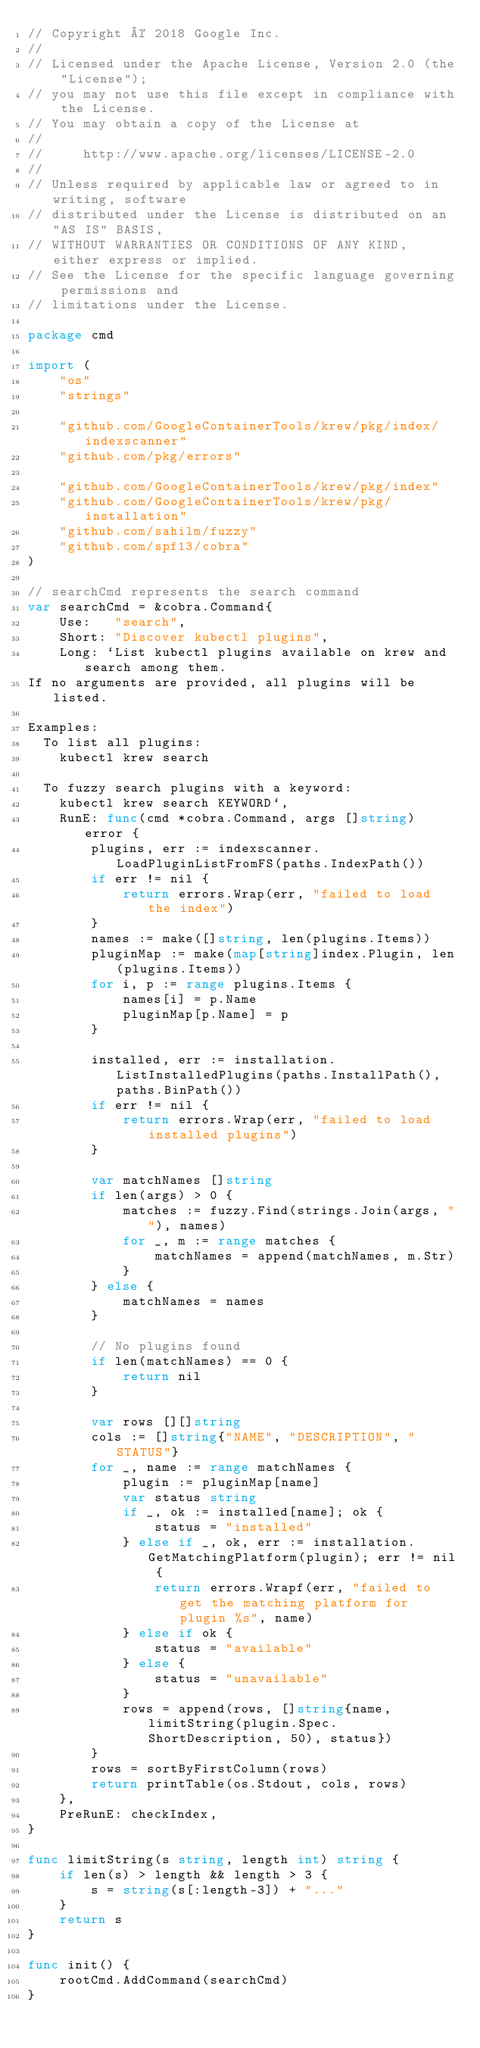Convert code to text. <code><loc_0><loc_0><loc_500><loc_500><_Go_>// Copyright © 2018 Google Inc.
//
// Licensed under the Apache License, Version 2.0 (the "License");
// you may not use this file except in compliance with the License.
// You may obtain a copy of the License at
//
//     http://www.apache.org/licenses/LICENSE-2.0
//
// Unless required by applicable law or agreed to in writing, software
// distributed under the License is distributed on an "AS IS" BASIS,
// WITHOUT WARRANTIES OR CONDITIONS OF ANY KIND, either express or implied.
// See the License for the specific language governing permissions and
// limitations under the License.

package cmd

import (
	"os"
	"strings"

	"github.com/GoogleContainerTools/krew/pkg/index/indexscanner"
	"github.com/pkg/errors"

	"github.com/GoogleContainerTools/krew/pkg/index"
	"github.com/GoogleContainerTools/krew/pkg/installation"
	"github.com/sahilm/fuzzy"
	"github.com/spf13/cobra"
)

// searchCmd represents the search command
var searchCmd = &cobra.Command{
	Use:   "search",
	Short: "Discover kubectl plugins",
	Long: `List kubectl plugins available on krew and search among them.
If no arguments are provided, all plugins will be listed.

Examples:
  To list all plugins:
    kubectl krew search

  To fuzzy search plugins with a keyword:
    kubectl krew search KEYWORD`,
	RunE: func(cmd *cobra.Command, args []string) error {
		plugins, err := indexscanner.LoadPluginListFromFS(paths.IndexPath())
		if err != nil {
			return errors.Wrap(err, "failed to load the index")
		}
		names := make([]string, len(plugins.Items))
		pluginMap := make(map[string]index.Plugin, len(plugins.Items))
		for i, p := range plugins.Items {
			names[i] = p.Name
			pluginMap[p.Name] = p
		}

		installed, err := installation.ListInstalledPlugins(paths.InstallPath(), paths.BinPath())
		if err != nil {
			return errors.Wrap(err, "failed to load installed plugins")
		}

		var matchNames []string
		if len(args) > 0 {
			matches := fuzzy.Find(strings.Join(args, ""), names)
			for _, m := range matches {
				matchNames = append(matchNames, m.Str)
			}
		} else {
			matchNames = names
		}

		// No plugins found
		if len(matchNames) == 0 {
			return nil
		}

		var rows [][]string
		cols := []string{"NAME", "DESCRIPTION", "STATUS"}
		for _, name := range matchNames {
			plugin := pluginMap[name]
			var status string
			if _, ok := installed[name]; ok {
				status = "installed"
			} else if _, ok, err := installation.GetMatchingPlatform(plugin); err != nil {
				return errors.Wrapf(err, "failed to get the matching platform for plugin %s", name)
			} else if ok {
				status = "available"
			} else {
				status = "unavailable"
			}
			rows = append(rows, []string{name, limitString(plugin.Spec.ShortDescription, 50), status})
		}
		rows = sortByFirstColumn(rows)
		return printTable(os.Stdout, cols, rows)
	},
	PreRunE: checkIndex,
}

func limitString(s string, length int) string {
	if len(s) > length && length > 3 {
		s = string(s[:length-3]) + "..."
	}
	return s
}

func init() {
	rootCmd.AddCommand(searchCmd)
}
</code> 